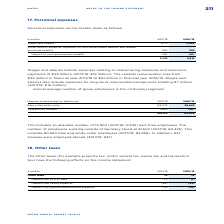According to Metro Ag's financial document, What are examples of taxes under Other taxes? property tax, motor vehicle tax, excise tax and transaction tax. The document states: "The other taxes (for example property tax, motor vehicle tax, excise tax and transaction tax) have the following effects on the income statement:..." Also, What was the amount of Other taxes in FY2019? According to the financial document, 79 (in millions). The relevant text states: "Other taxes 79 79..." Also, What are the costs or expenses under Other taxes in the table? The document contains multiple relevant values: thereof from cost of sales, thereof from selling expenses, thereof from general administrative expenses. From the document: "thereof from cost of sales (1) (1) thereof from selling expenses (65) (62) thereof from general administrative expenses (13) (16)..." Additionally, In which year was the amount of other taxes thereof from general administrative expenses larger? Based on the financial document, the answer is 2018/2019. Also, can you calculate: What was the change in Other taxes in 2018/2019 from 2017/2018? I cannot find a specific answer to this question in the financial document. Also, can you calculate: What was the percentage change in Other taxes in 2018/2019 from 2017/2018? I cannot find a specific answer to this question in the financial document. 